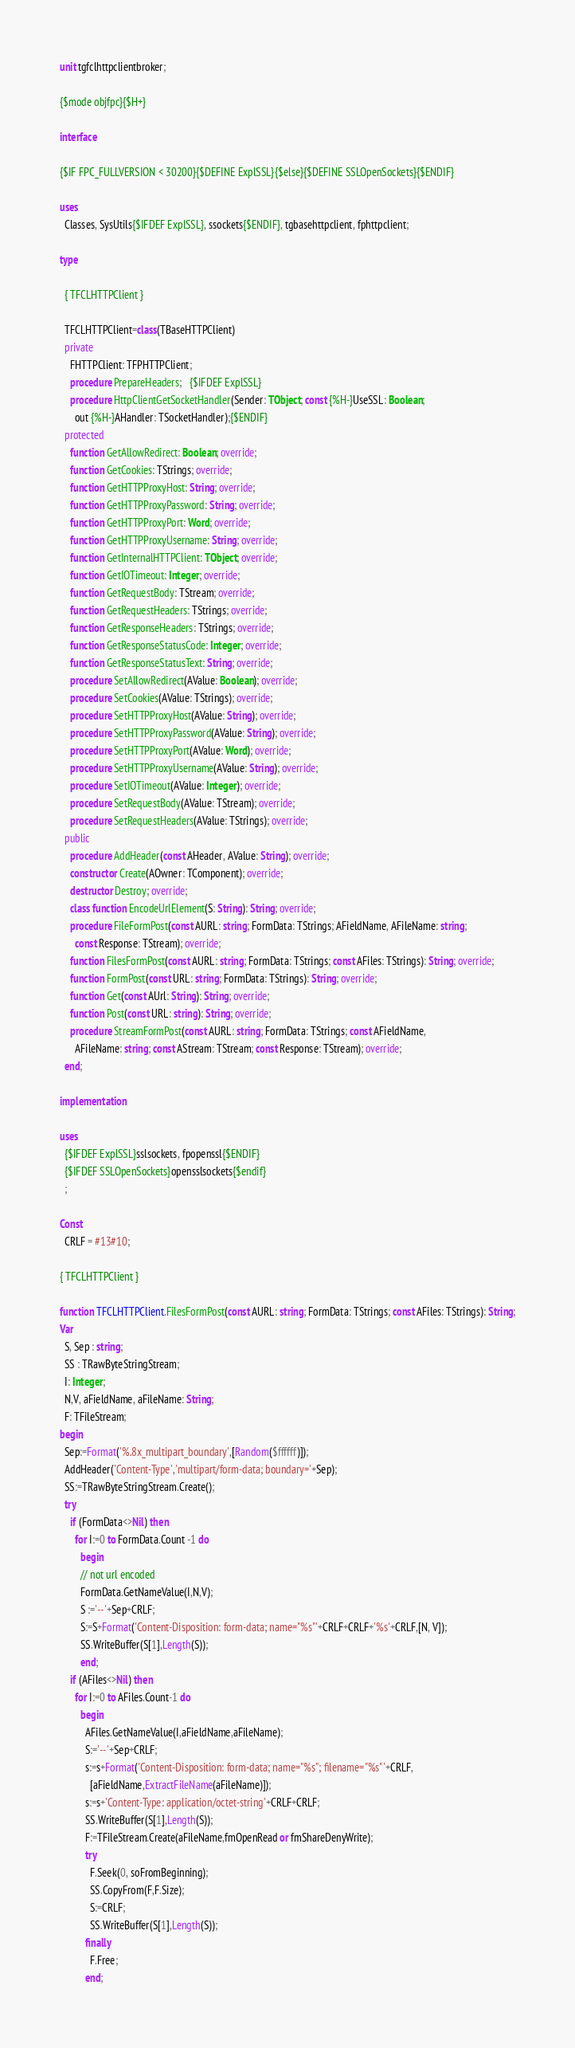<code> <loc_0><loc_0><loc_500><loc_500><_Pascal_>unit tgfclhttpclientbroker;

{$mode objfpc}{$H+}

interface

{$IF FPC_FULLVERSION < 30200}{$DEFINE ExplSSL}{$else}{$DEFINE SSLOpenSockets}{$ENDIF}

uses
  Classes, SysUtils{$IFDEF ExplSSL}, ssockets{$ENDIF}, tgbasehttpclient, fphttpclient;

type

  { TFCLHTTPClient }

  TFCLHTTPClient=class(TBaseHTTPClient)
  private
    FHTTPClient: TFPHTTPClient;
    procedure PrepareHeaders;   {$IFDEF ExplSSL}
    procedure HttpClientGetSocketHandler(Sender: TObject; const {%H-}UseSSL: Boolean;
      out {%H-}AHandler: TSocketHandler);{$ENDIF}
  protected
    function GetAllowRedirect: Boolean; override;
    function GetCookies: TStrings; override;
    function GetHTTPProxyHost: String; override;
    function GetHTTPProxyPassword: String; override;
    function GetHTTPProxyPort: Word; override;
    function GetHTTPProxyUsername: String; override;
    function GetInternalHTTPClient: TObject; override;
    function GetIOTimeout: Integer; override;
    function GetRequestBody: TStream; override;
    function GetRequestHeaders: TStrings; override;
    function GetResponseHeaders: TStrings; override;
    function GetResponseStatusCode: Integer; override;
    function GetResponseStatusText: String; override;
    procedure SetAllowRedirect(AValue: Boolean); override;
    procedure SetCookies(AValue: TStrings); override;
    procedure SetHTTPProxyHost(AValue: String); override;
    procedure SetHTTPProxyPassword(AValue: String); override;
    procedure SetHTTPProxyPort(AValue: Word); override;
    procedure SetHTTPProxyUsername(AValue: String); override;
    procedure SetIOTimeout(AValue: Integer); override;
    procedure SetRequestBody(AValue: TStream); override;
    procedure SetRequestHeaders(AValue: TStrings); override;
  public
    procedure AddHeader(const AHeader, AValue: String); override;
    constructor Create(AOwner: TComponent); override;
    destructor Destroy; override;
    class function EncodeUrlElement(S: String): String; override;
    procedure FileFormPost(const AURL: string; FormData: TStrings; AFieldName, AFileName: string;
      const Response: TStream); override;    
    function FilesFormPost(const AURL: string; FormData: TStrings; const AFiles: TStrings): String; override;
    function FormPost(const URL: string; FormData: TStrings): String; override;
    function Get(const AUrl: String): String; override;
    function Post(const URL: string): String; override;
    procedure StreamFormPost(const AURL: string; FormData: TStrings; const AFieldName,
      AFileName: string; const AStream: TStream; const Response: TStream); override;
  end;

implementation

uses
  {$IFDEF ExplSSL}sslsockets, fpopenssl{$ENDIF}
  {$IFDEF SSLOpenSockets}opensslsockets{$endif}
  ;

Const
  CRLF = #13#10;

{ TFCLHTTPClient }

function TFCLHTTPClient.FilesFormPost(const AURL: string; FormData: TStrings; const AFiles: TStrings): String;
Var
  S, Sep : string;
  SS : TRawByteStringStream;
  I: Integer;
  N,V, aFieldName, aFileName: String;
  F: TFileStream;
begin
  Sep:=Format('%.8x_multipart_boundary',[Random($ffffff)]);
  AddHeader('Content-Type','multipart/form-data; boundary='+Sep);
  SS:=TRawByteStringStream.Create();
  try
    if (FormData<>Nil) then
      for I:=0 to FormData.Count -1 do
        begin
        // not url encoded
        FormData.GetNameValue(I,N,V);
        S :='--'+Sep+CRLF;
        S:=S+Format('Content-Disposition: form-data; name="%s"'+CRLF+CRLF+'%s'+CRLF,[N, V]);
        SS.WriteBuffer(S[1],Length(S));
        end;
    if (AFiles<>Nil) then
      for I:=0 to AFiles.Count-1 do
        begin             
          AFiles.GetNameValue(I,aFieldName,aFileName);
          S:='--'+Sep+CRLF;
          s:=s+Format('Content-Disposition: form-data; name="%s"; filename="%s"'+CRLF,
            [aFieldName,ExtractFileName(aFileName)]);
          s:=s+'Content-Type: application/octet-string'+CRLF+CRLF;
          SS.WriteBuffer(S[1],Length(S));
          F:=TFileStream.Create(aFileName,fmOpenRead or fmShareDenyWrite);
          try
            F.Seek(0, soFromBeginning);
            SS.CopyFrom(F,F.Size);
            S:=CRLF;
            SS.WriteBuffer(S[1],Length(S));
          finally
            F.Free;
          end;</code> 